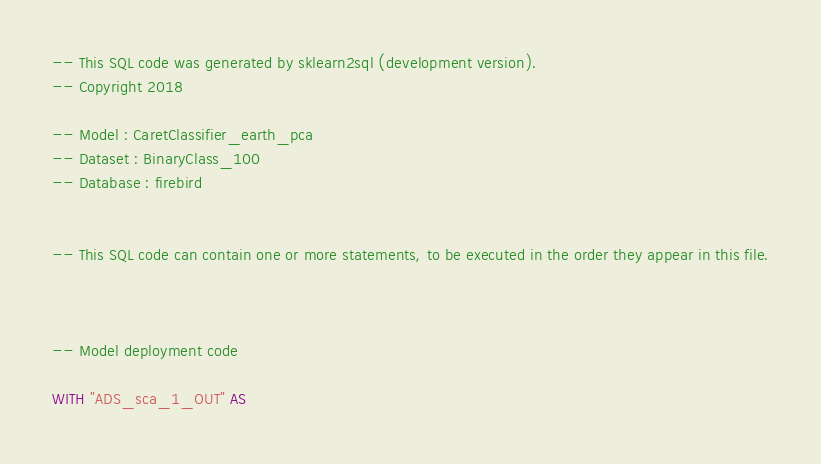<code> <loc_0><loc_0><loc_500><loc_500><_SQL_>-- This SQL code was generated by sklearn2sql (development version).
-- Copyright 2018

-- Model : CaretClassifier_earth_pca
-- Dataset : BinaryClass_100
-- Database : firebird


-- This SQL code can contain one or more statements, to be executed in the order they appear in this file.



-- Model deployment code

WITH "ADS_sca_1_OUT" AS </code> 